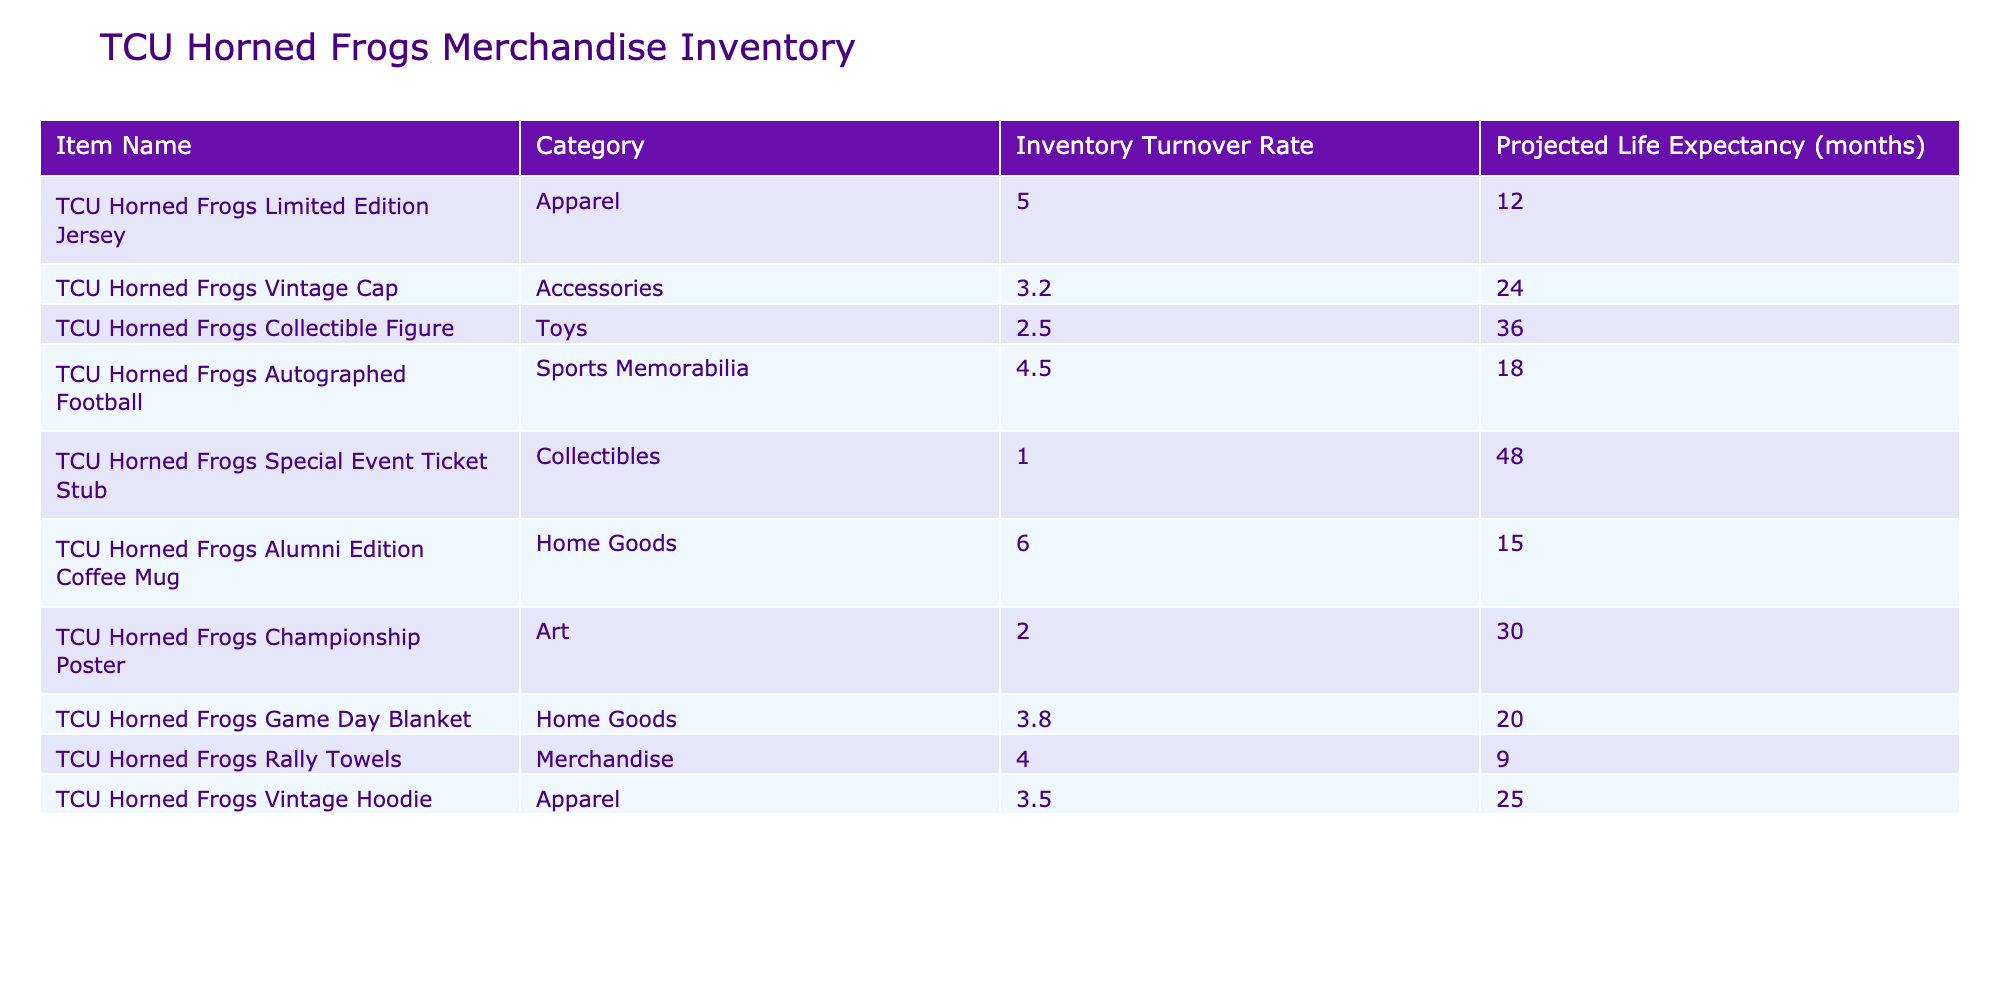What is the inventory turnover rate for the TCU Horned Frogs Vintage Cap? The table indicates that the inventory turnover rate for the TCU Horned Frogs Vintage Cap is 3.2. This value is found in the corresponding row under the "Inventory Turnover Rate" column.
Answer: 3.2 Which item has the highest projected life expectancy? The item with the highest projected life expectancy is the TCU Horned Frogs Special Event Ticket Stub, which has a life expectancy of 48 months. We determine this by comparing the projected life expectancy values in each row.
Answer: 48 months What is the average inventory turnover rate of all items listed in the table? To find the average inventory turnover rate, we sum the turnover rates: 5.0 + 3.2 + 2.5 + 4.5 + 1.0 + 6.0 + 2.0 + 3.8 + 4.0 + 3.5 = 32.5. There are 10 items; therefore, the average is 32.5 / 10 = 3.25.
Answer: 3.25 Is the inventory turnover rate for the TCU Horned Frogs Alumni Edition Coffee Mug higher than 4.0? The inventory turnover rate for the TCU Horned Frogs Alumni Edition Coffee Mug is 6.0, which is higher than 4.0 as indicated in the table.
Answer: Yes Which category has the item with the lowest inventory turnover rate? The item with the lowest inventory turnover rate is the TCU Horned Frogs Special Event Ticket Stub in the Collectibles category, which has a turnover rate of 1.0. By examining each category and their rates, this conclusion can be drawn.
Answer: Collectibles 